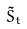<formula> <loc_0><loc_0><loc_500><loc_500>\tilde { S } _ { t }</formula> 